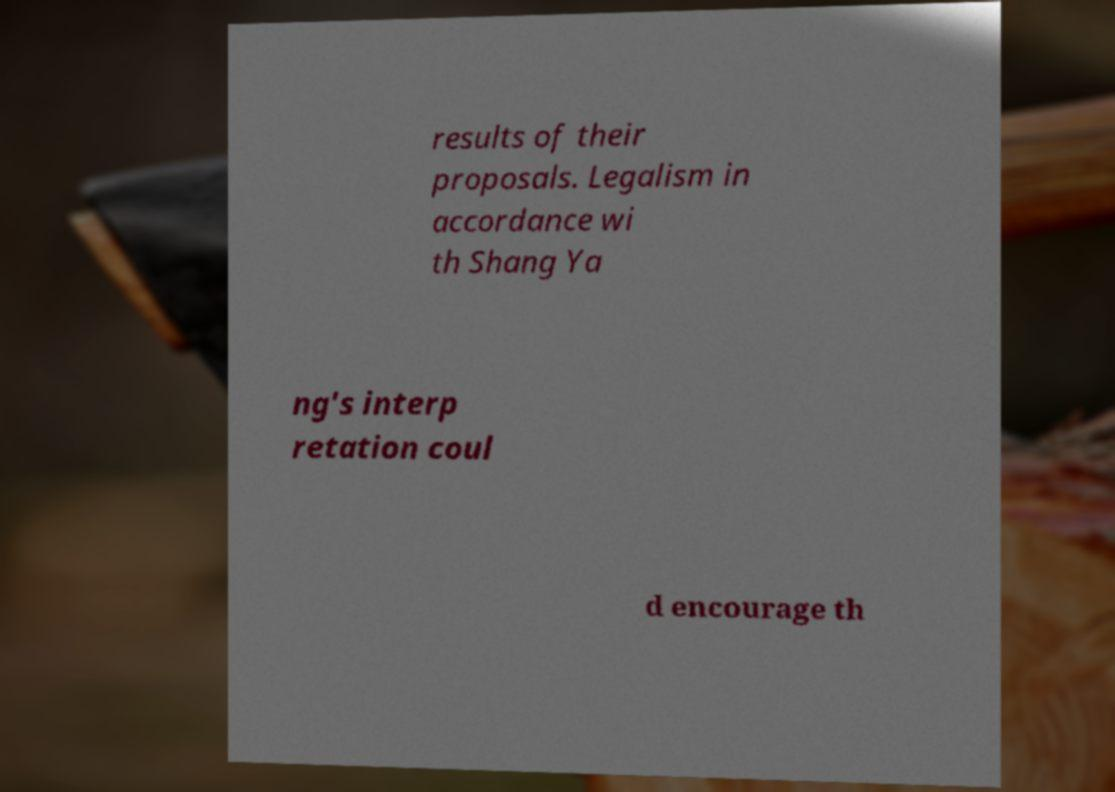Can you read and provide the text displayed in the image?This photo seems to have some interesting text. Can you extract and type it out for me? results of their proposals. Legalism in accordance wi th Shang Ya ng's interp retation coul d encourage th 